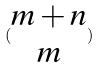<formula> <loc_0><loc_0><loc_500><loc_500>( \begin{matrix} m + n \\ m \end{matrix} )</formula> 